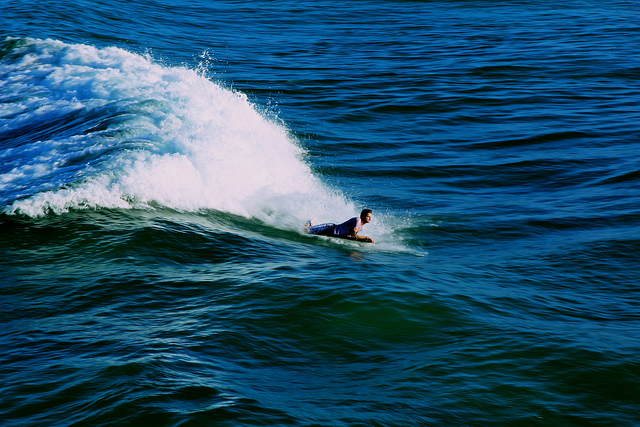<image>Will the wave overtake the man? It is ambiguous if the wave will overtake the man. Will the wave overtake the man? I don't know yet if the wave will overtake the man. It is uncertain and can go either way. 